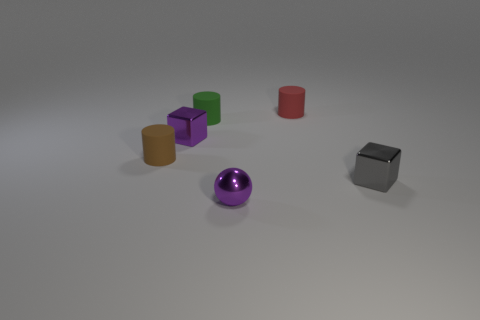Subtract all tiny red cylinders. How many cylinders are left? 2 Add 4 big gray cylinders. How many objects exist? 10 Subtract 1 cylinders. How many cylinders are left? 2 Subtract all green cylinders. How many cylinders are left? 2 Subtract all blocks. How many objects are left? 4 Subtract all red matte objects. Subtract all small purple balls. How many objects are left? 4 Add 3 things. How many things are left? 9 Add 3 green rubber cylinders. How many green rubber cylinders exist? 4 Subtract 1 red cylinders. How many objects are left? 5 Subtract all gray balls. Subtract all cyan cylinders. How many balls are left? 1 